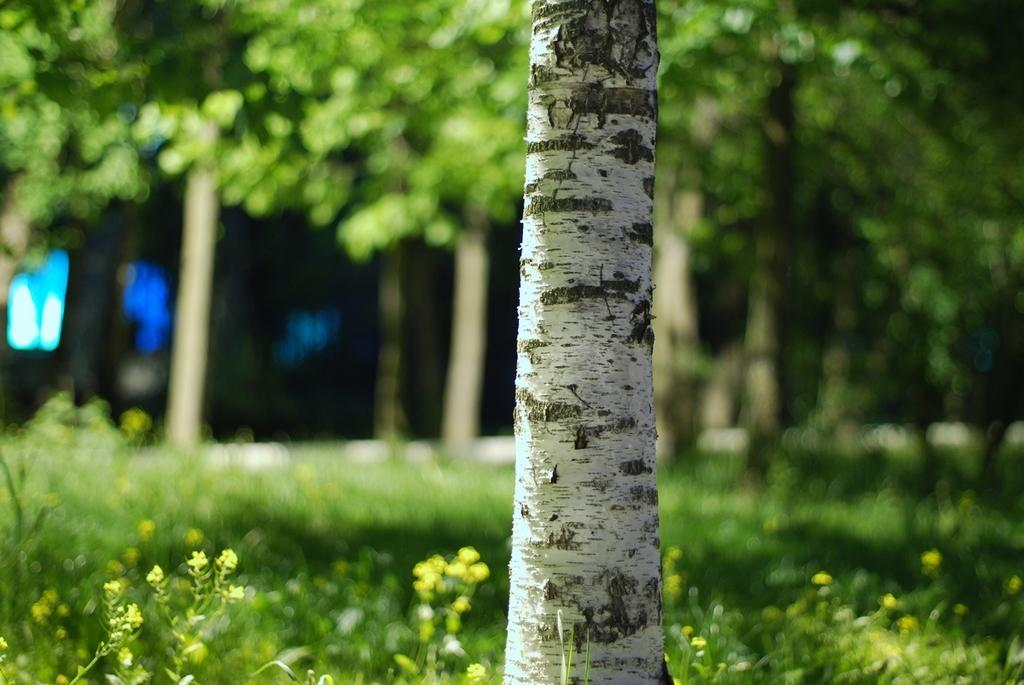What is the main subject of the image? The main subject of the image is a tree trunk. How would you describe the background of the image? The background of the image is slightly blurred. What type of vegetation can be seen in the background? Grass, plants, and trees are visible in the background of the image. What type of fiction is the son reading in the image? There is no son or any reading material present in the image. 